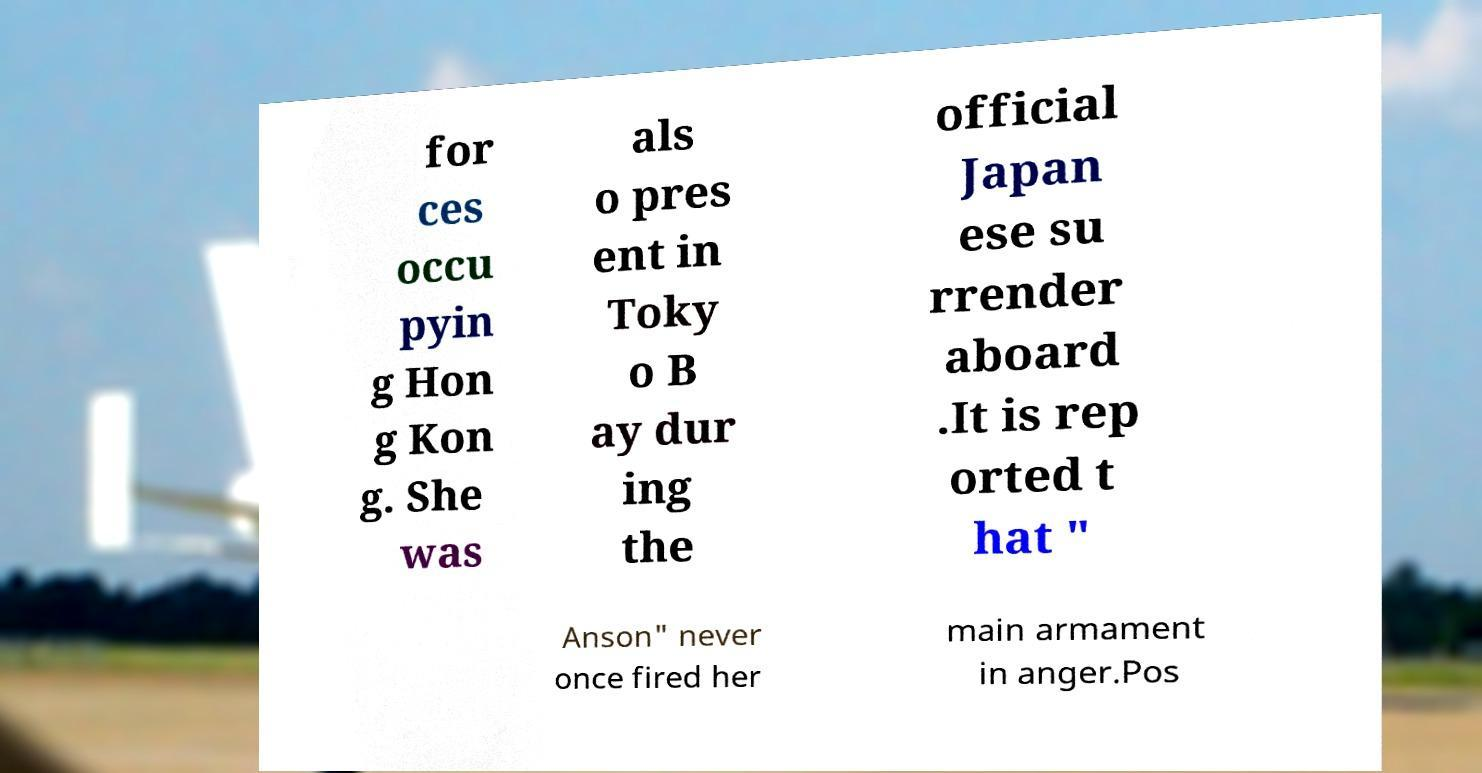What messages or text are displayed in this image? I need them in a readable, typed format. for ces occu pyin g Hon g Kon g. She was als o pres ent in Toky o B ay dur ing the official Japan ese su rrender aboard .It is rep orted t hat " Anson" never once fired her main armament in anger.Pos 